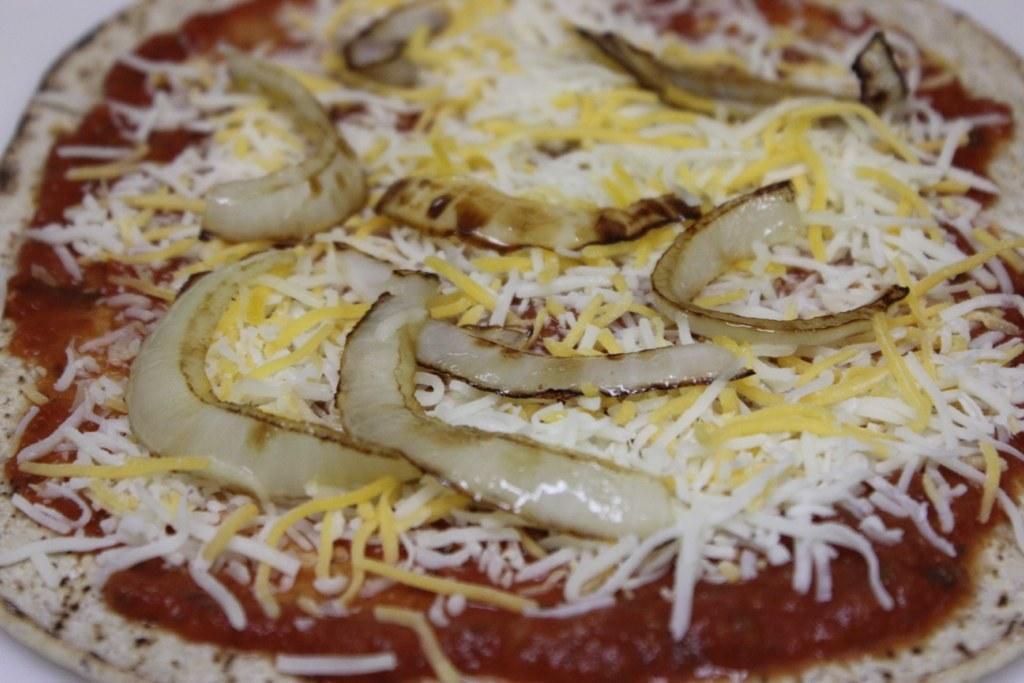Could you give a brief overview of what you see in this image? In this picture we can see bread, onion pieces and coconut pieces which is kept on the table. 